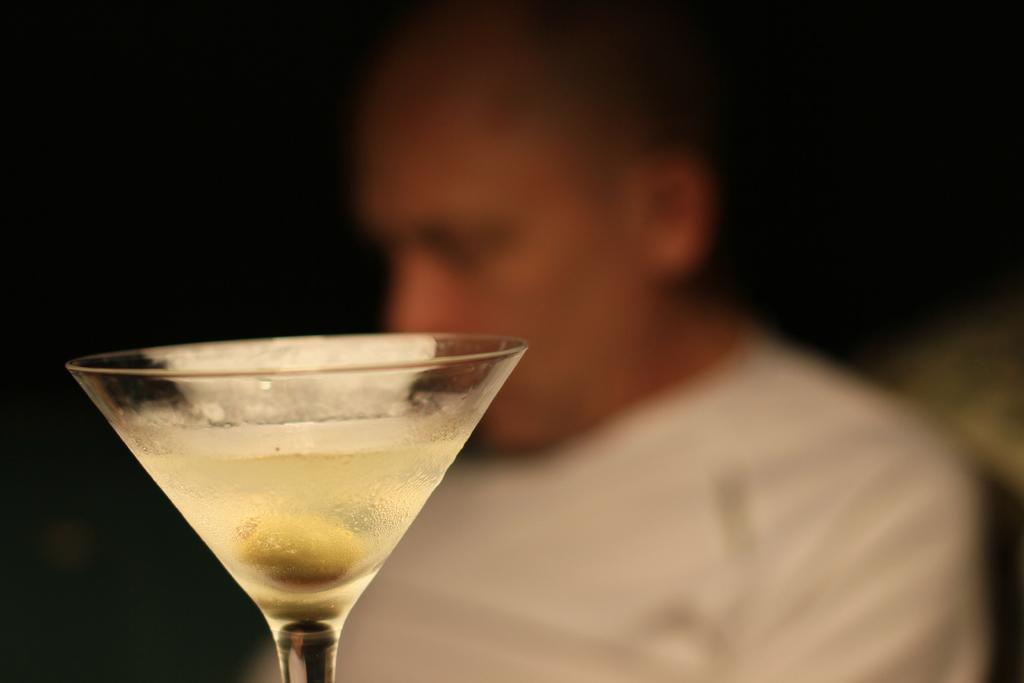What can be seen inside the glass in the image? There is a drink in the glass. Is there anything else visible at the bottom of the glass? Yes, there is an object at the bottom of the glass. Who is present behind the glass? There is a person behind the glass. How would you describe the background of the image? The background of the image is blurry. How many babies are crawling on the table in the image? There are no babies present in the image; it only features a glass with a drink and an object at the bottom, a person behind the glass, and a blurry background. 